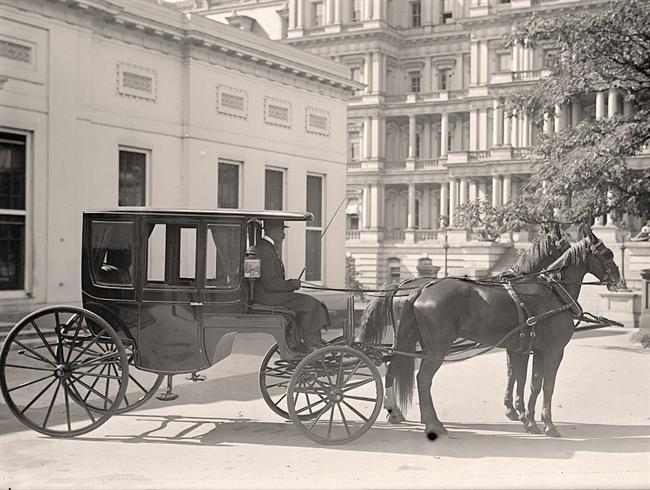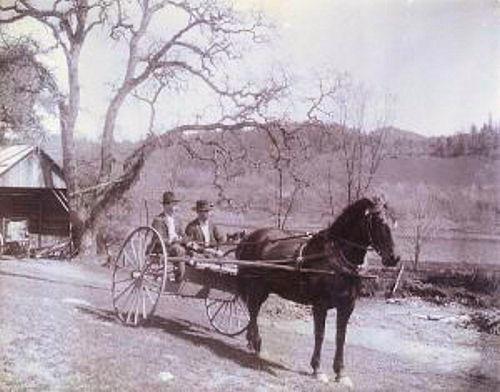The first image is the image on the left, the second image is the image on the right. For the images shown, is this caption "One of the carriages is carrying an oversized load." true? Answer yes or no. No. The first image is the image on the left, the second image is the image on the right. For the images displayed, is the sentence "In one image, two people are sitting in a carriage with only two large wheels, which is pulled by one horse." factually correct? Answer yes or no. Yes. 